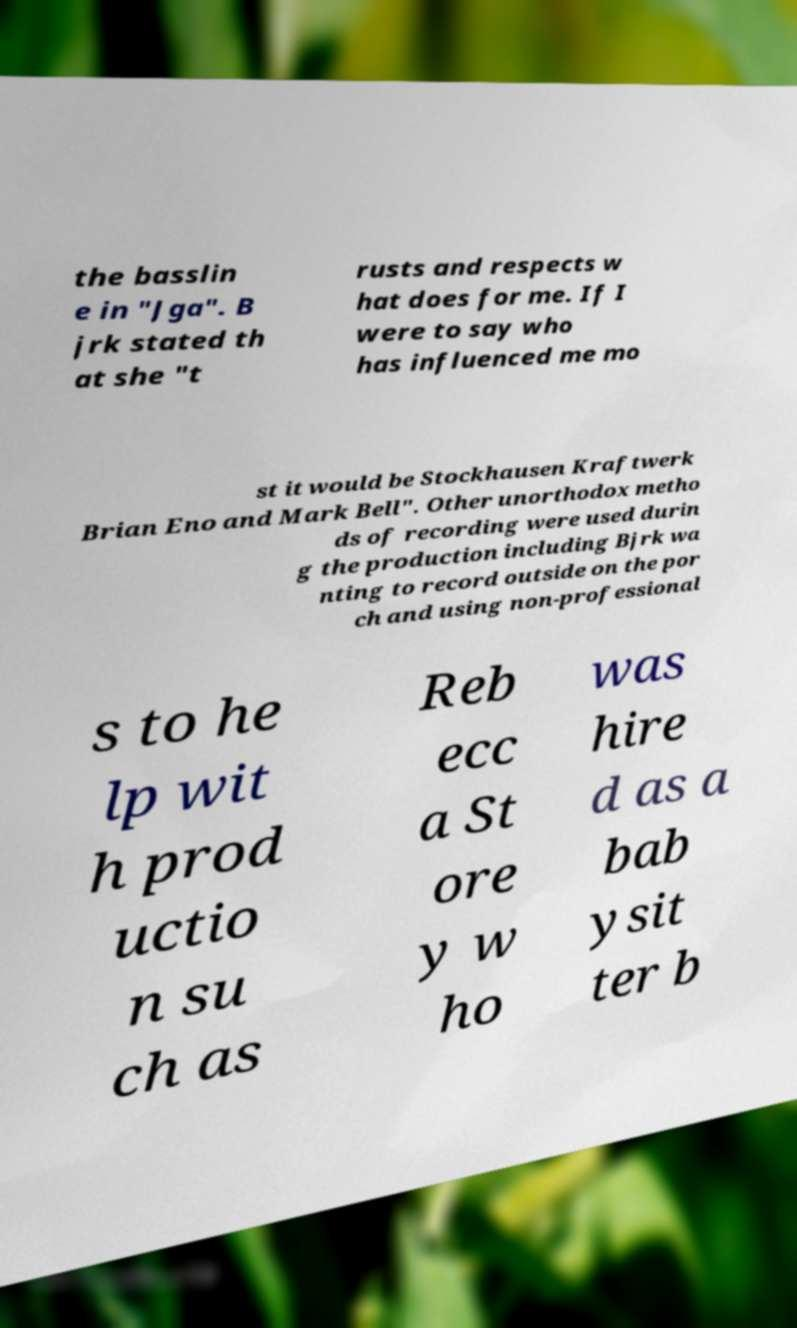Please identify and transcribe the text found in this image. the basslin e in "Jga". B jrk stated th at she "t rusts and respects w hat does for me. If I were to say who has influenced me mo st it would be Stockhausen Kraftwerk Brian Eno and Mark Bell". Other unorthodox metho ds of recording were used durin g the production including Bjrk wa nting to record outside on the por ch and using non-professional s to he lp wit h prod uctio n su ch as Reb ecc a St ore y w ho was hire d as a bab ysit ter b 